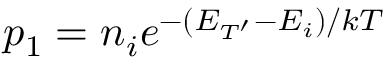<formula> <loc_0><loc_0><loc_500><loc_500>p _ { 1 } = n _ { i } e ^ { - ( E _ { T ^ { \prime } } - E _ { i } ) / k T }</formula> 